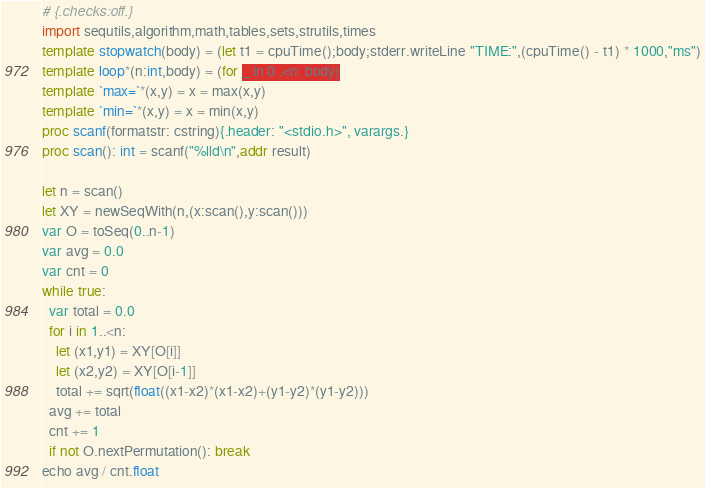Convert code to text. <code><loc_0><loc_0><loc_500><loc_500><_Nim_># {.checks:off.}
import sequtils,algorithm,math,tables,sets,strutils,times
template stopwatch(body) = (let t1 = cpuTime();body;stderr.writeLine "TIME:",(cpuTime() - t1) * 1000,"ms")
template loop*(n:int,body) = (for _ in 0..<n: body)
template `max=`*(x,y) = x = max(x,y)
template `min=`*(x,y) = x = min(x,y)
proc scanf(formatstr: cstring){.header: "<stdio.h>", varargs.}
proc scan(): int = scanf("%lld\n",addr result)

let n = scan()
let XY = newSeqWith(n,(x:scan(),y:scan()))
var O = toSeq(0..n-1)
var avg = 0.0
var cnt = 0
while true:
  var total = 0.0
  for i in 1..<n:
    let (x1,y1) = XY[O[i]]
    let (x2,y2) = XY[O[i-1]]
    total += sqrt(float((x1-x2)*(x1-x2)+(y1-y2)*(y1-y2)))
  avg += total
  cnt += 1
  if not O.nextPermutation(): break
echo avg / cnt.float
</code> 